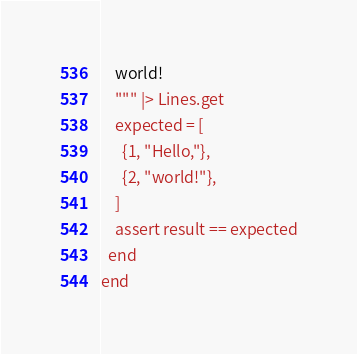Convert code to text. <code><loc_0><loc_0><loc_500><loc_500><_Elixir_>    world!
    """ |> Lines.get
    expected = [
      {1, "Hello,"},
      {2, "world!"},
    ]
    assert result == expected
  end
end
</code> 